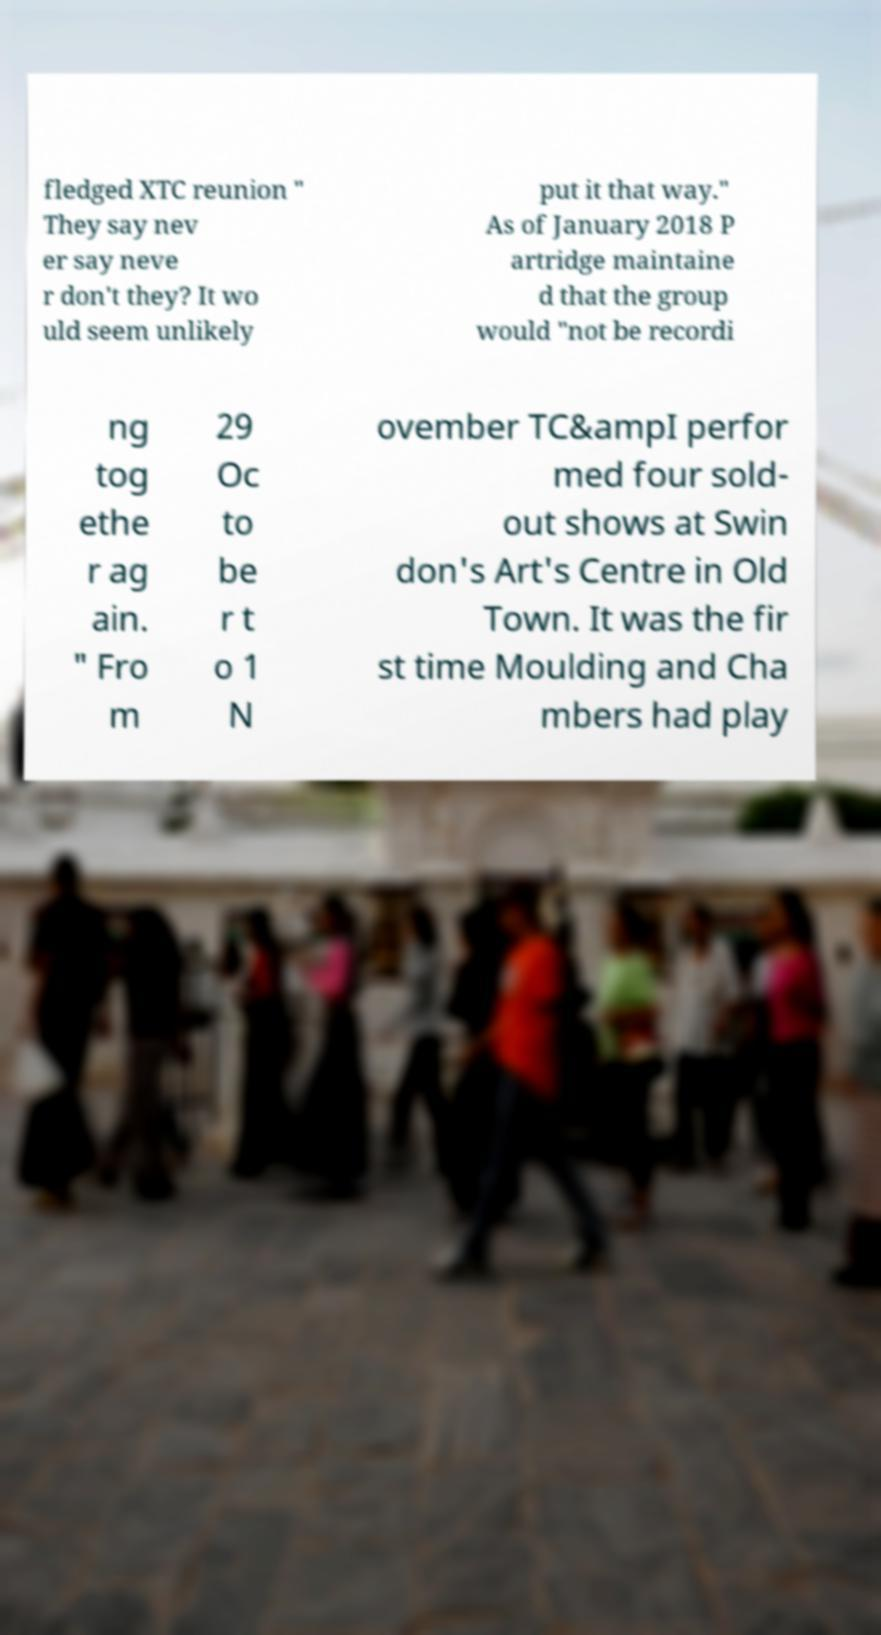Can you read and provide the text displayed in the image?This photo seems to have some interesting text. Can you extract and type it out for me? fledged XTC reunion " They say nev er say neve r don't they? It wo uld seem unlikely put it that way." As of January 2018 P artridge maintaine d that the group would "not be recordi ng tog ethe r ag ain. " Fro m 29 Oc to be r t o 1 N ovember TC&ampI perfor med four sold- out shows at Swin don's Art's Centre in Old Town. It was the fir st time Moulding and Cha mbers had play 